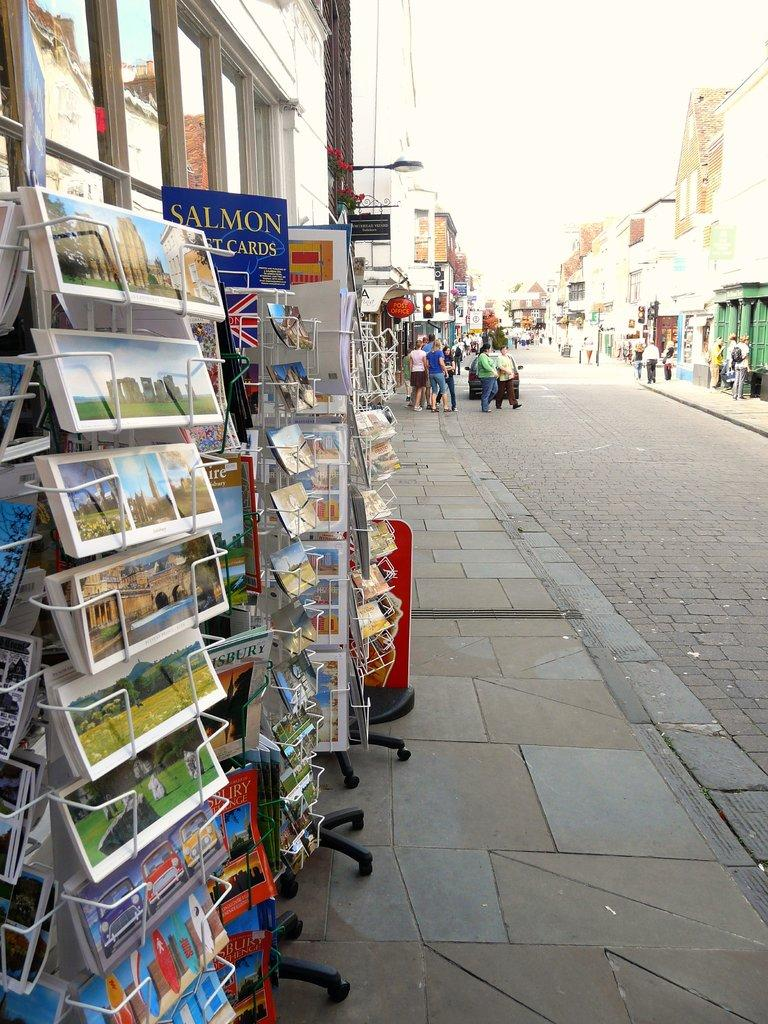<image>
Present a compact description of the photo's key features. Several displays of Salmon post cards are on an outdoor sidewalk. 